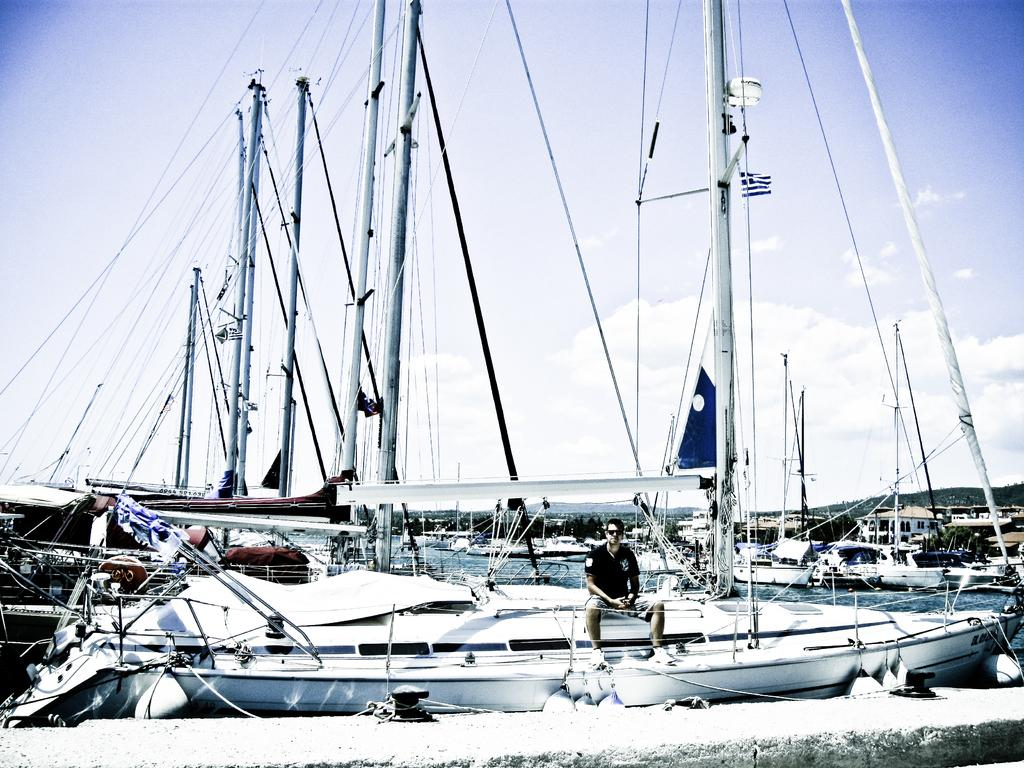What type of vehicles are in the water in the image? There are ships in the water in the image. What is the man in the image doing? The man is sitting in one of the ships. What can be seen on the right side of the image? There are hills on the right side of the image. What is visible in the background of the image? The sky is visible in the background of the image. What type of owl can be seen perched on the ship's mast in the image? There is no owl present in the image; it features ships in the water with a man sitting in one of them. What is the man using to tie up the ship in the image? There is no string or any indication of tying up the ship in the image. 